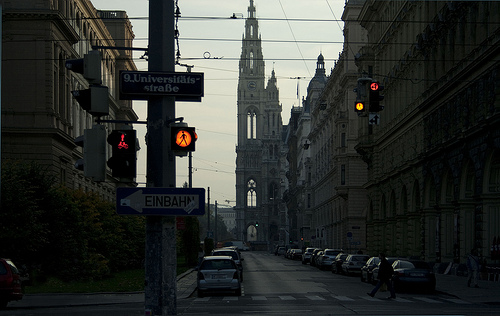How many lights are on? There are four lights visible in the image that are illuminated. It's interesting to notice how the artificial light contrasts with the natural lighting, giving a sense of the time of day as either early morning or evening. 